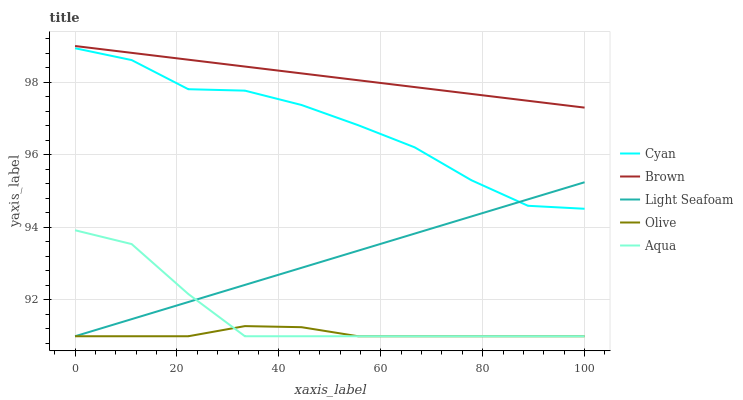Does Olive have the minimum area under the curve?
Answer yes or no. Yes. Does Brown have the maximum area under the curve?
Answer yes or no. Yes. Does Cyan have the minimum area under the curve?
Answer yes or no. No. Does Cyan have the maximum area under the curve?
Answer yes or no. No. Is Light Seafoam the smoothest?
Answer yes or no. Yes. Is Cyan the roughest?
Answer yes or no. Yes. Is Cyan the smoothest?
Answer yes or no. No. Is Light Seafoam the roughest?
Answer yes or no. No. Does Olive have the lowest value?
Answer yes or no. Yes. Does Cyan have the lowest value?
Answer yes or no. No. Does Brown have the highest value?
Answer yes or no. Yes. Does Cyan have the highest value?
Answer yes or no. No. Is Olive less than Brown?
Answer yes or no. Yes. Is Cyan greater than Olive?
Answer yes or no. Yes. Does Cyan intersect Light Seafoam?
Answer yes or no. Yes. Is Cyan less than Light Seafoam?
Answer yes or no. No. Is Cyan greater than Light Seafoam?
Answer yes or no. No. Does Olive intersect Brown?
Answer yes or no. No. 